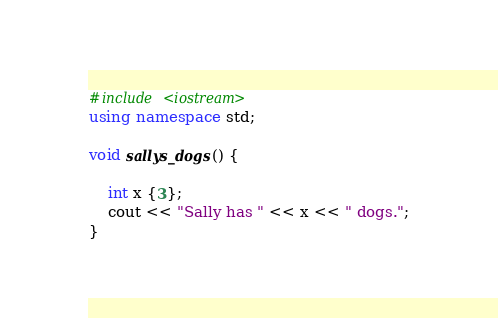Convert code to text. <code><loc_0><loc_0><loc_500><loc_500><_C++_>#include <iostream>
using namespace std;

void sallys_dogs() {
    
    int x {3}; 
    cout << "Sally has " << x << " dogs.";
}</code> 